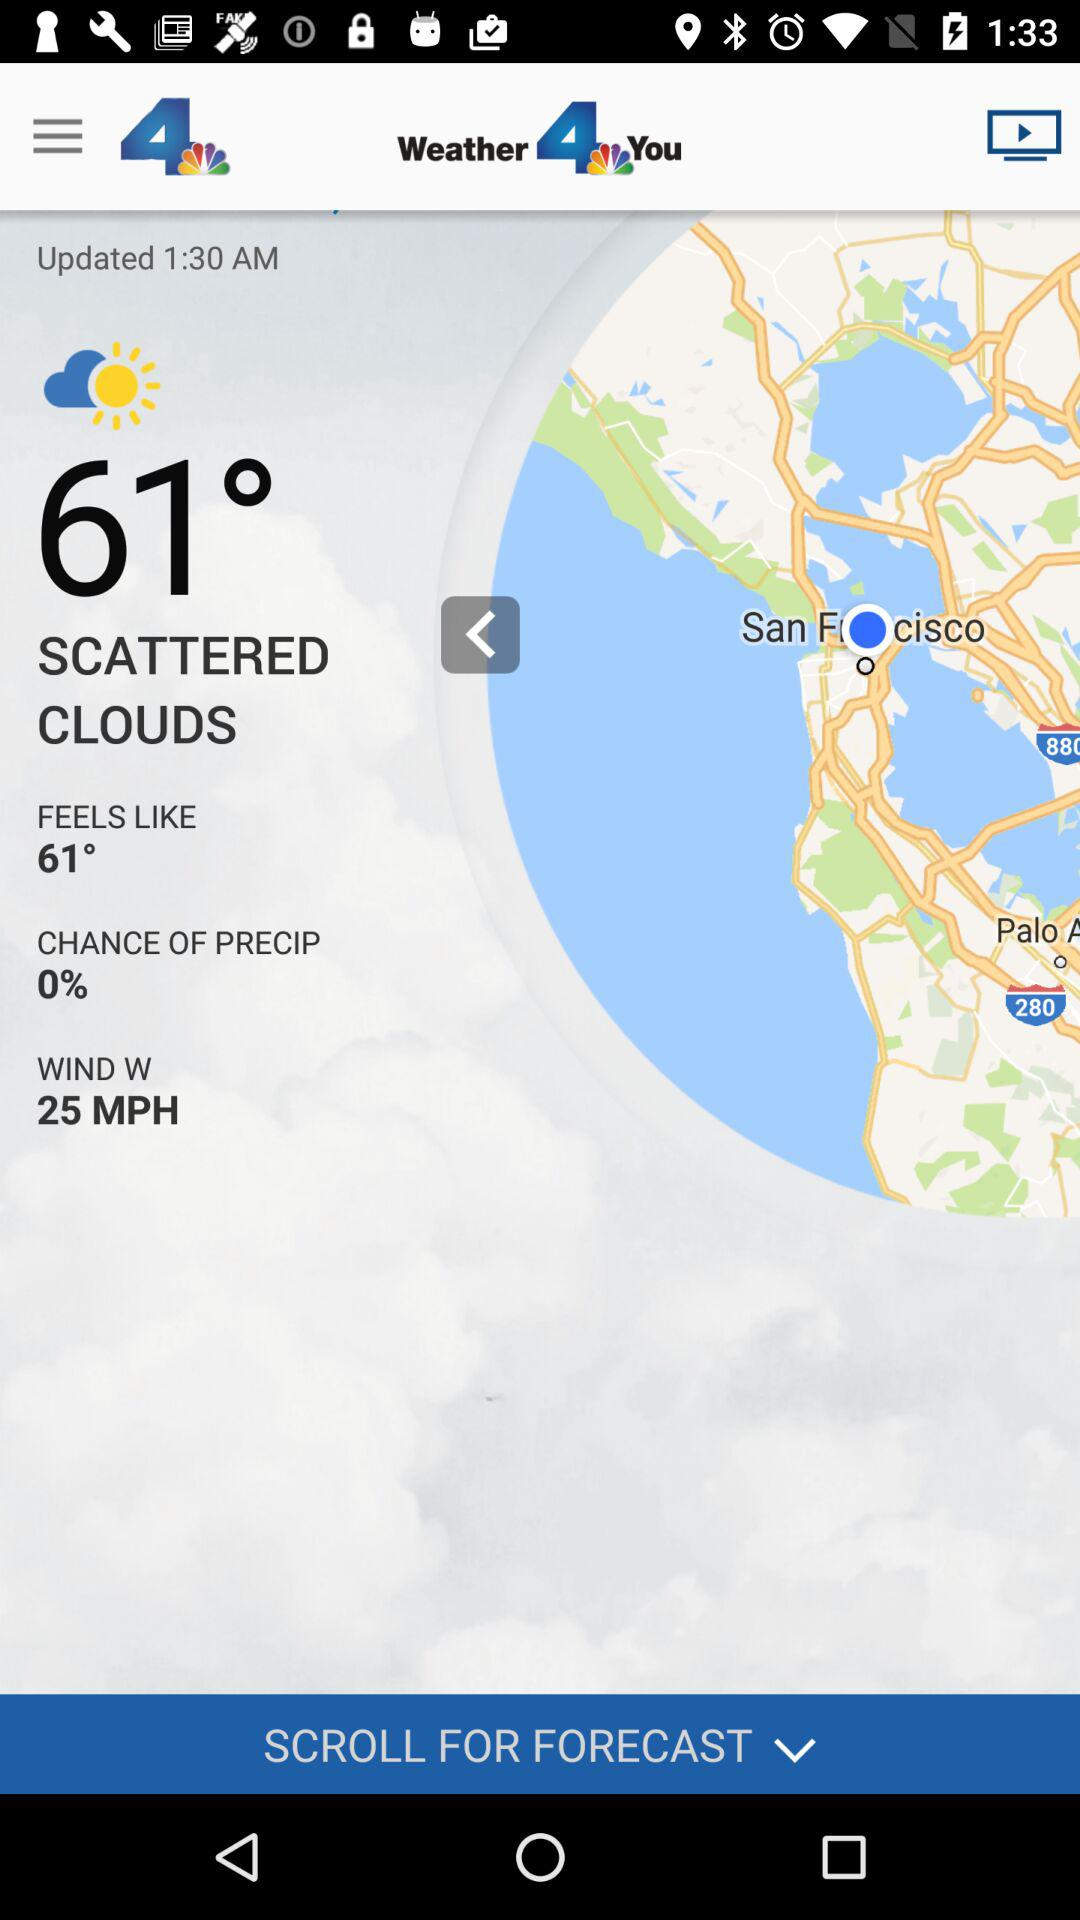What is the percentage chance of precipitation?
Answer the question using a single word or phrase. 0% 